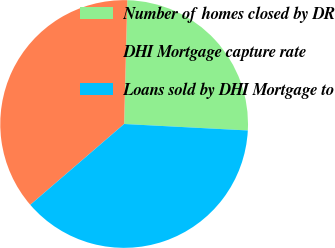Convert chart. <chart><loc_0><loc_0><loc_500><loc_500><pie_chart><fcel>Number of homes closed by DR<fcel>DHI Mortgage capture rate<fcel>Loans sold by DHI Mortgage to<nl><fcel>25.42%<fcel>36.72%<fcel>37.85%<nl></chart> 